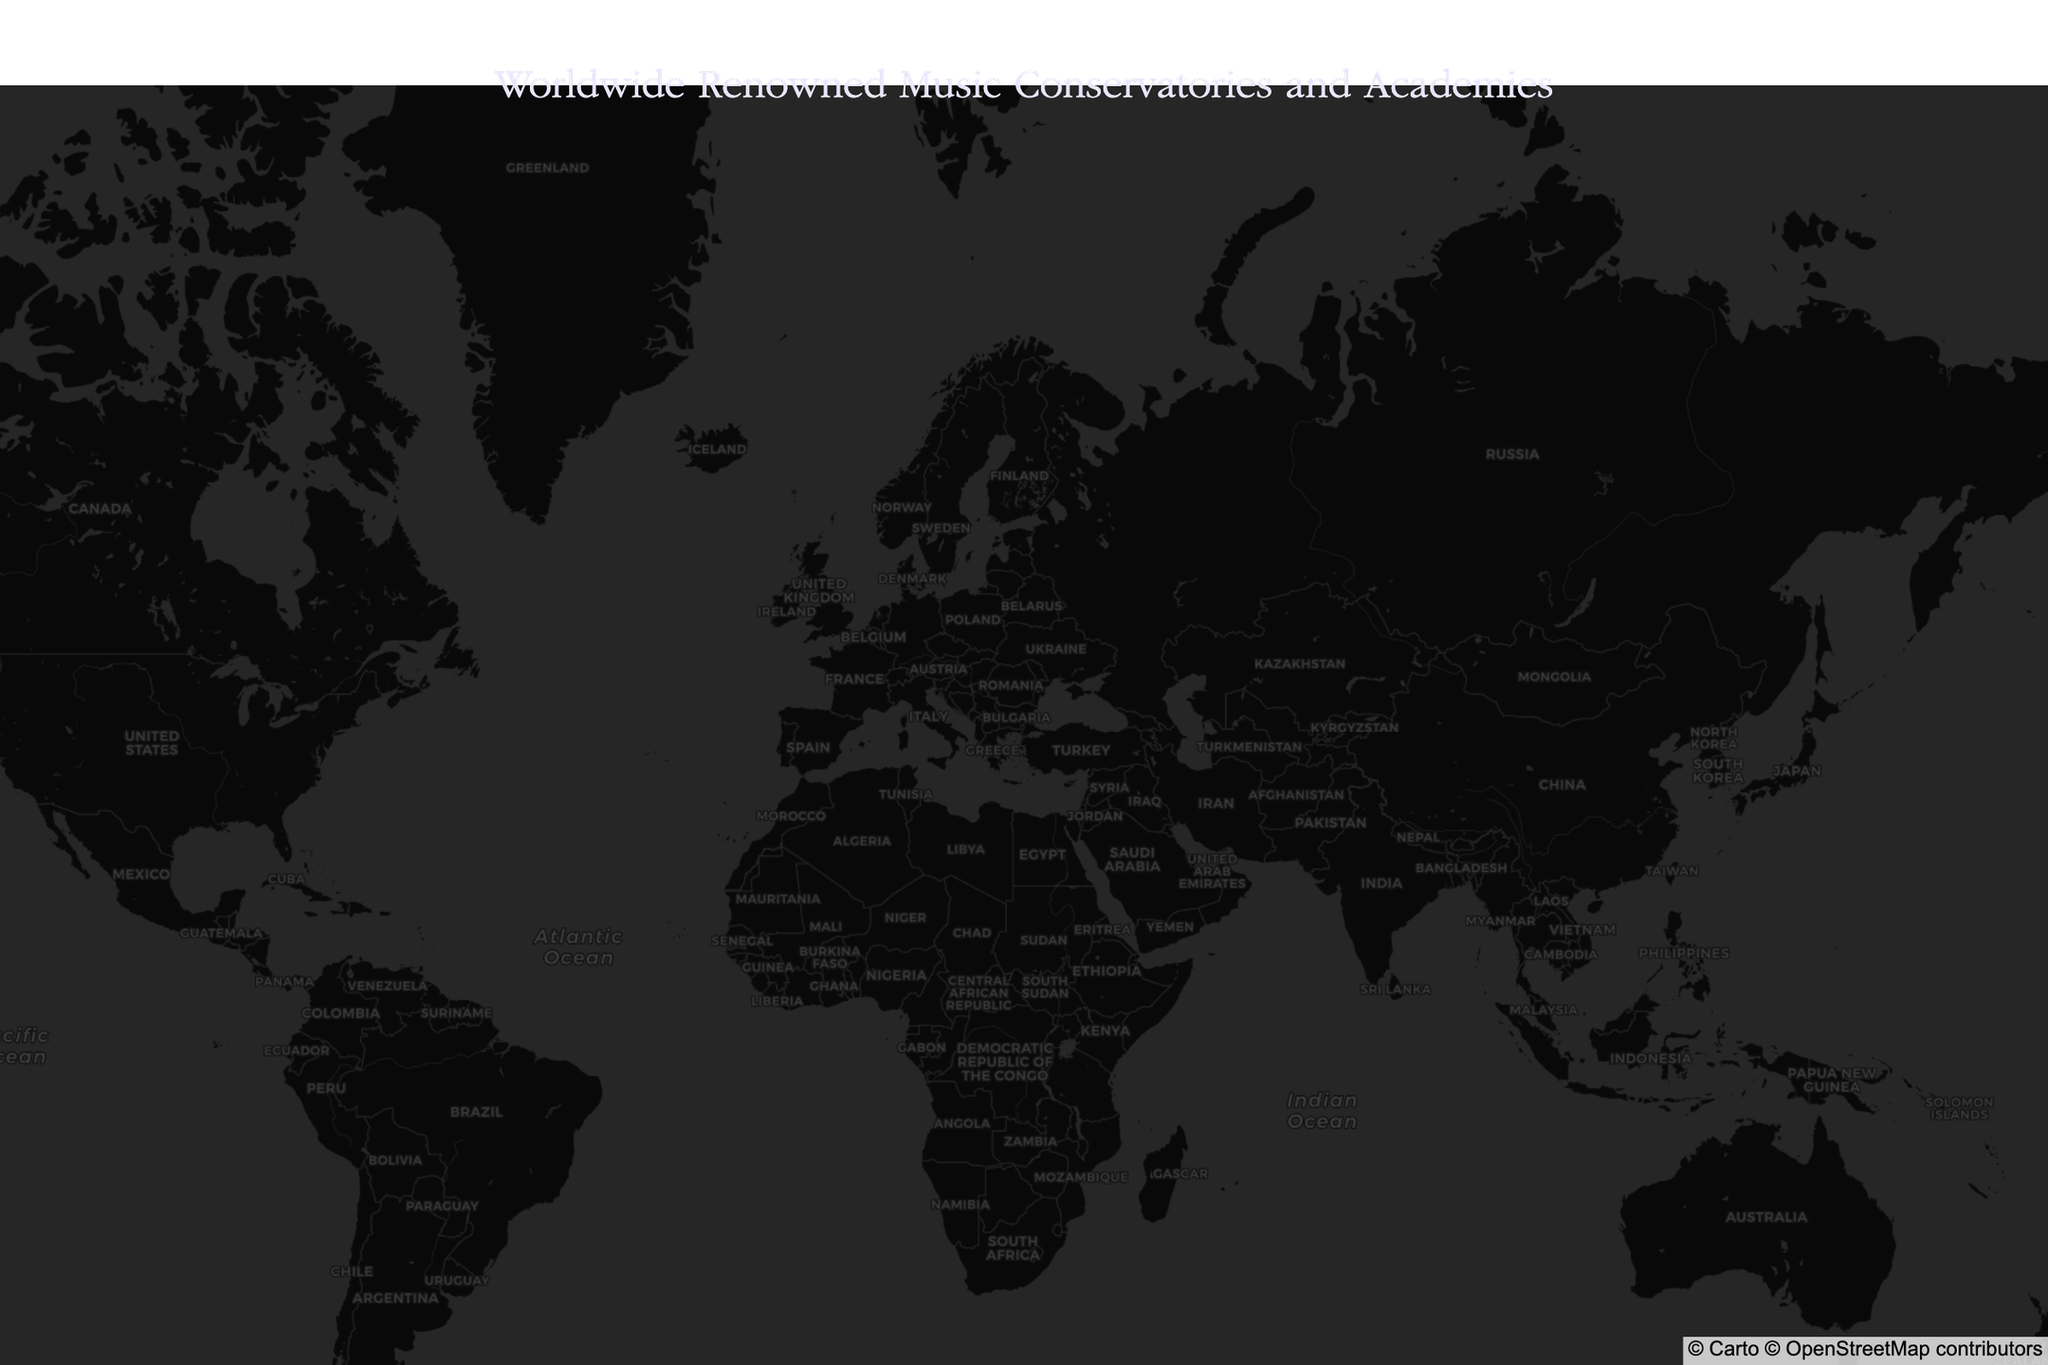What is the title of the map? The map title is prominently displayed at the top center of the figure. It reads "Worldwide Renowned Music Conservatories and Academies".
Answer: Worldwide Renowned Music Conservatories and Academies How many countries have a renowned music conservatory or academy indicated on this map? By visually counting the unique countries associated with each conservatory or academy on the map, we identify a total of 11 countries (USA, UK, France, Russia, Austria, Finland, Belgium, Germany, Australia, Japan, Italy, and China).
Answer: 11 Which music conservatory is located the furthest north? By comparing the latitude values presented on the map, we see that Sibelius Academy in Helsinki, Finland, has the highest northern latitude (60.1756).
Answer: Sibelius Academy What continents are represented on this map? Observing the geographic distribution of the music conservatories and academies, we find they are located in North America, Europe, Asia, and Australia.
Answer: North America, Europe, Asia, and Australia How many music conservatories are located in the USA according to this map? By examining the data points and noting the country tags, we identify two conservatories located in the USA: Juilliard School in New York City and Berklee College of Music in Boston.
Answer: 2 Which conservatory is closest to the equator? By evaluating the absolute latitude values (proximity to zero), the music conservatory nearest to the equator is the Sydney Conservatorium of Music in Sydney, Australia (latitude -33.8621).
Answer: Sydney Conservatorium of Music What's the median latitude of all the institutions? Sorting the latitude values and finding the middle value, the median is calculated as follows: 
North: [-33.8621, 31.2304, 35.7185, 40.7645, 42.3467, 45.4668, 48.2082, 48.8699, 50.8422, 51.4998, 52.5144, 55.7566, 55.8657, 60.1756]. The middle elements for this even-numbered list are 45.4668 and 48.2082. So, the median is the average of these two: (45.4668 + 48.2082) / 2 = 46.8375
Answer: 46.8375 Which two conservatories are closest to each other based on their coordinates? By visually checking the proximity of the points on the map, we determine that the Juilliard School (New York City, USA) and Berklee College of Music (Boston, USA) are the closest since both are in the northeastern USA.
Answer: Juilliard School and Berklee College of Music What is the average longitude of the institutions located in Europe? By summing the longitudes for European institutions and dividing by their number, we perform the following:
London (Royal College of Music): -0.1774, Paris (Conservatoire de Paris): 2.3304, Moscow (Moscow Conservatory): 37.6077, Vienna (Vienna Conservatory): 16.3738, Helsinki (Sibelius Academy): 24.9342, Brussels (Royal Conservatory of Brussels): 4.3693, Berlin (Hochschule für Musik Hanns Eisler): 13.3897, Glasgow (Royal Conservatoire of Scotland): -4.2517, Milan (Conservatorio di Milano): 9.1905. 
Total longitude sum: 103.7659
Number of European institutions: 9
Average longitude = 103.7659 / 9 = 11.5295
Answer: 11.5295 